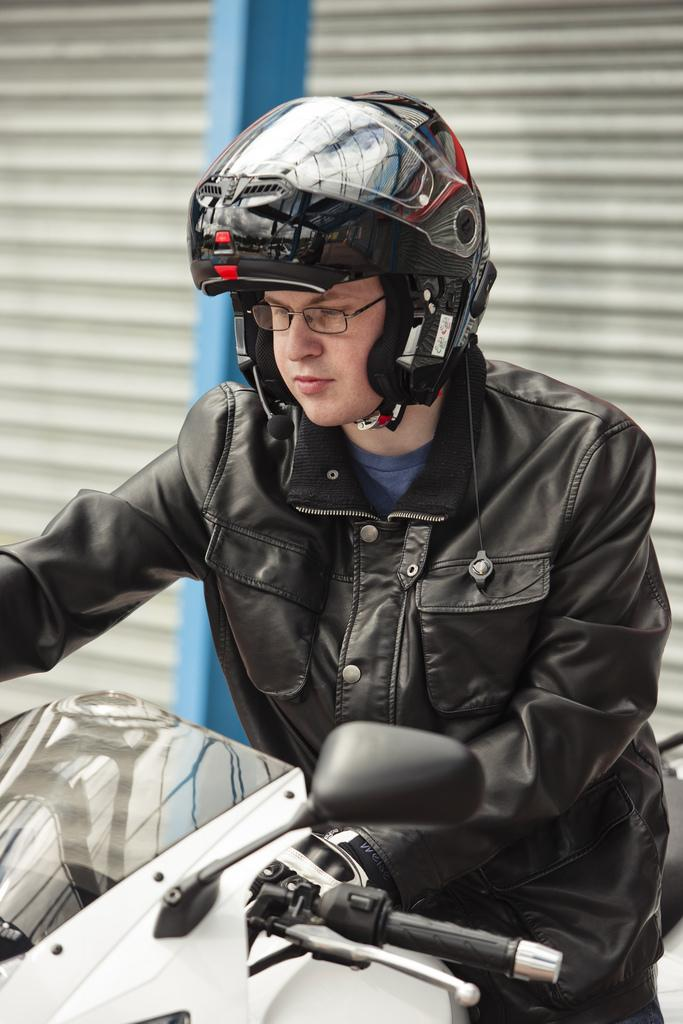Who is present in the image? There is a man in the image. What is the man wearing on his head? The man is wearing a helmet. What else is the man wearing? The man is wearing spectacles, a jacket, and trousers. What is the man standing near? The man is standing near a bike. What can be seen in the background of the image? There is a shelter and a blue color pole visible in the background. What type of map can be seen in the image? There is no map present in the image. Can you tell me how the man moves the hill in the image? There is no hill present in the image, and the man is not shown moving anything. 